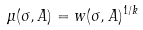<formula> <loc_0><loc_0><loc_500><loc_500>\mu ( \sigma , A ) = w ( \sigma , A ) ^ { 1 / k }</formula> 